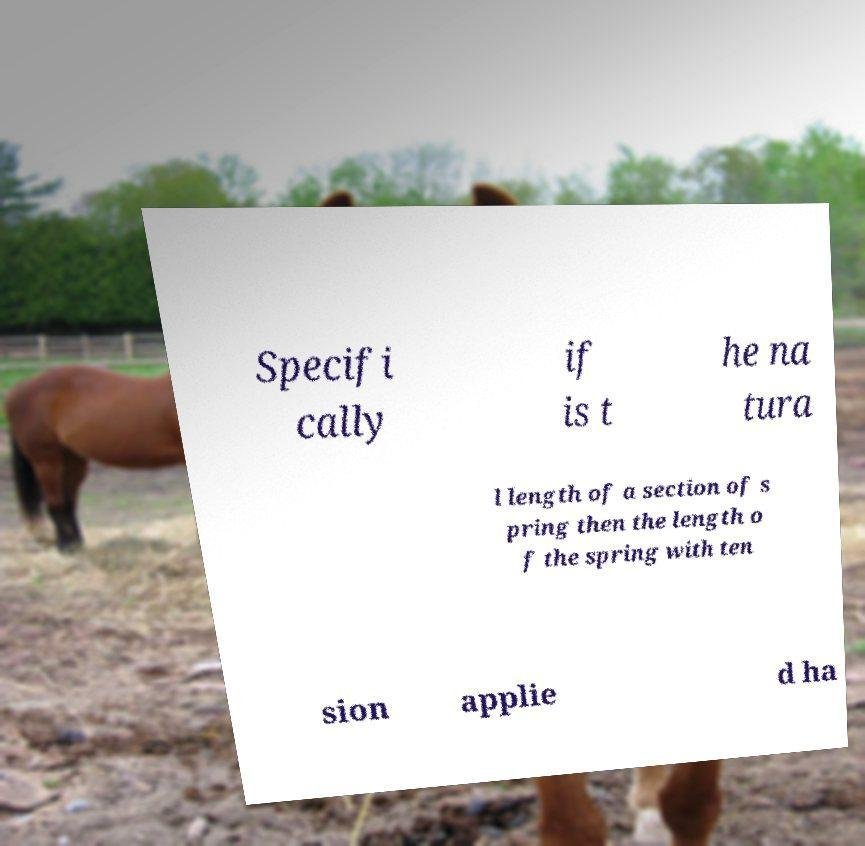There's text embedded in this image that I need extracted. Can you transcribe it verbatim? Specifi cally if is t he na tura l length of a section of s pring then the length o f the spring with ten sion applie d ha 